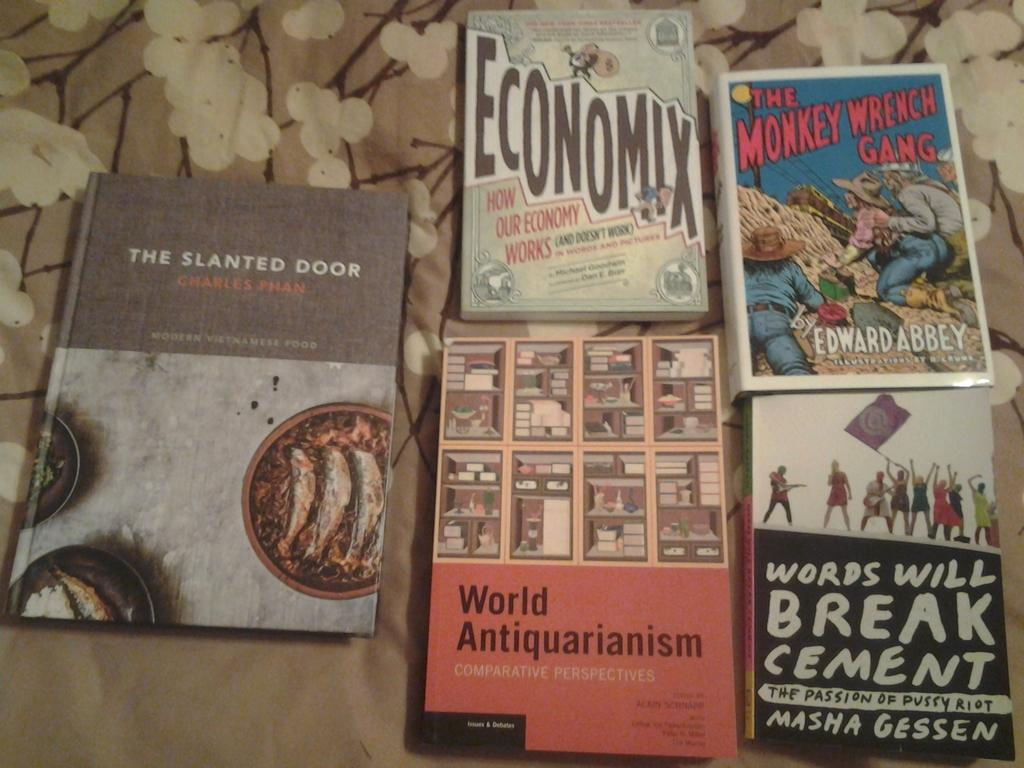<image>
Offer a succinct explanation of the picture presented. a book that has the word economix on it 